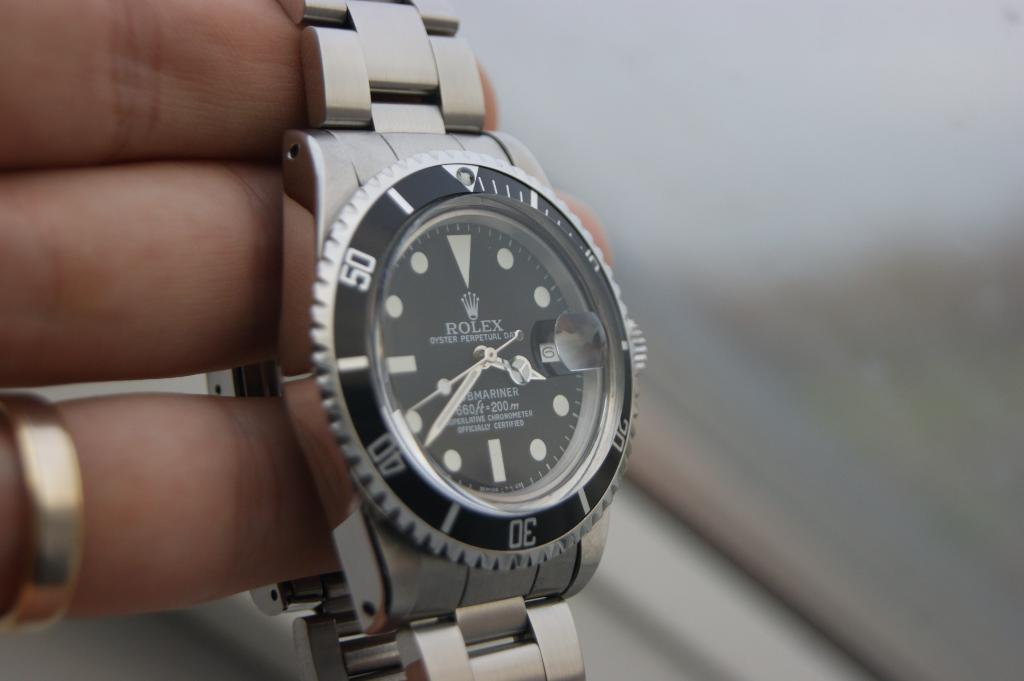<image>
Render a clear and concise summary of the photo. Someone wearing a wedding ring is holding out a Rolex watch. 